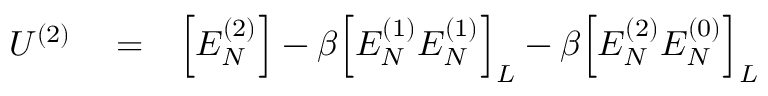Convert formula to latex. <formula><loc_0><loc_0><loc_500><loc_500>\begin{array} { r l r } { U ^ { ( 2 ) } } & = } & { \left [ E _ { N } ^ { ( 2 ) } \right ] - \beta \left [ E _ { N } ^ { ( 1 ) } E _ { N } ^ { ( 1 ) } \right ] _ { L } - \beta \left [ E _ { N } ^ { ( 2 ) } E _ { N } ^ { ( 0 ) } \right ] _ { L } } \end{array}</formula> 